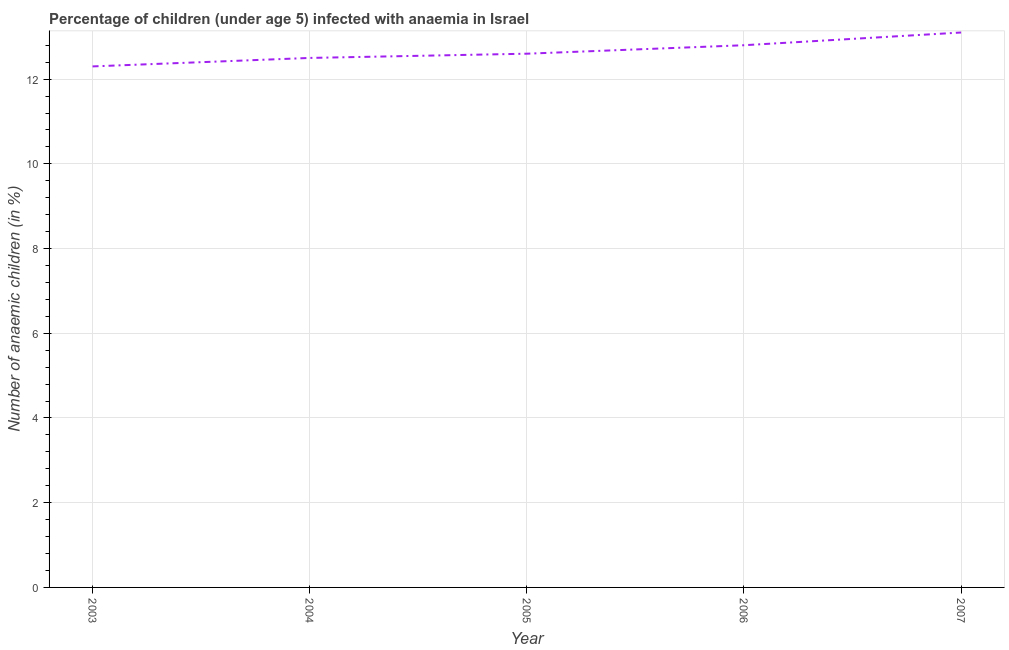What is the number of anaemic children in 2005?
Your answer should be very brief. 12.6. Across all years, what is the maximum number of anaemic children?
Give a very brief answer. 13.1. Across all years, what is the minimum number of anaemic children?
Provide a succinct answer. 12.3. In which year was the number of anaemic children minimum?
Your response must be concise. 2003. What is the sum of the number of anaemic children?
Provide a succinct answer. 63.3. What is the difference between the number of anaemic children in 2005 and 2006?
Make the answer very short. -0.2. What is the average number of anaemic children per year?
Provide a short and direct response. 12.66. What is the ratio of the number of anaemic children in 2003 to that in 2006?
Keep it short and to the point. 0.96. Is the difference between the number of anaemic children in 2004 and 2007 greater than the difference between any two years?
Ensure brevity in your answer.  No. What is the difference between the highest and the second highest number of anaemic children?
Give a very brief answer. 0.3. What is the difference between the highest and the lowest number of anaemic children?
Give a very brief answer. 0.8. Does the number of anaemic children monotonically increase over the years?
Provide a short and direct response. Yes. How many lines are there?
Keep it short and to the point. 1. What is the difference between two consecutive major ticks on the Y-axis?
Your answer should be compact. 2. Are the values on the major ticks of Y-axis written in scientific E-notation?
Make the answer very short. No. Does the graph contain any zero values?
Your answer should be very brief. No. Does the graph contain grids?
Your answer should be very brief. Yes. What is the title of the graph?
Provide a succinct answer. Percentage of children (under age 5) infected with anaemia in Israel. What is the label or title of the Y-axis?
Your answer should be very brief. Number of anaemic children (in %). What is the Number of anaemic children (in %) in 2003?
Offer a very short reply. 12.3. What is the Number of anaemic children (in %) of 2004?
Give a very brief answer. 12.5. What is the Number of anaemic children (in %) of 2006?
Offer a very short reply. 12.8. What is the difference between the Number of anaemic children (in %) in 2004 and 2005?
Offer a very short reply. -0.1. What is the difference between the Number of anaemic children (in %) in 2004 and 2007?
Your answer should be very brief. -0.6. What is the difference between the Number of anaemic children (in %) in 2005 and 2006?
Provide a succinct answer. -0.2. What is the difference between the Number of anaemic children (in %) in 2006 and 2007?
Your response must be concise. -0.3. What is the ratio of the Number of anaemic children (in %) in 2003 to that in 2005?
Your response must be concise. 0.98. What is the ratio of the Number of anaemic children (in %) in 2003 to that in 2006?
Your answer should be compact. 0.96. What is the ratio of the Number of anaemic children (in %) in 2003 to that in 2007?
Your response must be concise. 0.94. What is the ratio of the Number of anaemic children (in %) in 2004 to that in 2005?
Your response must be concise. 0.99. What is the ratio of the Number of anaemic children (in %) in 2004 to that in 2006?
Your response must be concise. 0.98. What is the ratio of the Number of anaemic children (in %) in 2004 to that in 2007?
Make the answer very short. 0.95. What is the ratio of the Number of anaemic children (in %) in 2005 to that in 2006?
Offer a very short reply. 0.98. What is the ratio of the Number of anaemic children (in %) in 2006 to that in 2007?
Make the answer very short. 0.98. 